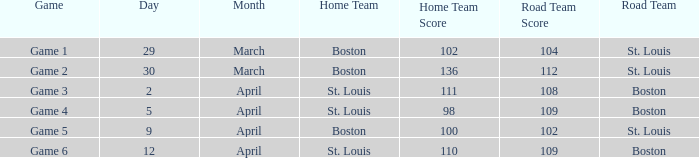Would you mind parsing the complete table? {'header': ['Game', 'Day', 'Month', 'Home Team', 'Home Team Score', 'Road Team Score', 'Road Team'], 'rows': [['Game 1', '29', 'March', 'Boston', '102', '104', 'St. Louis'], ['Game 2', '30', 'March', 'Boston', '136', '112', 'St. Louis'], ['Game 3', '2', 'April', 'St. Louis', '111', '108', 'Boston'], ['Game 4', '5', 'April', 'St. Louis', '98', '109', 'Boston'], ['Game 5', '9', 'April', 'Boston', '100', '102', 'St. Louis'], ['Game 6', '12', 'April', 'St. Louis', '110', '109', 'Boston']]} What is the Game number on April 12 with St. Louis Home Team? Game 6. 